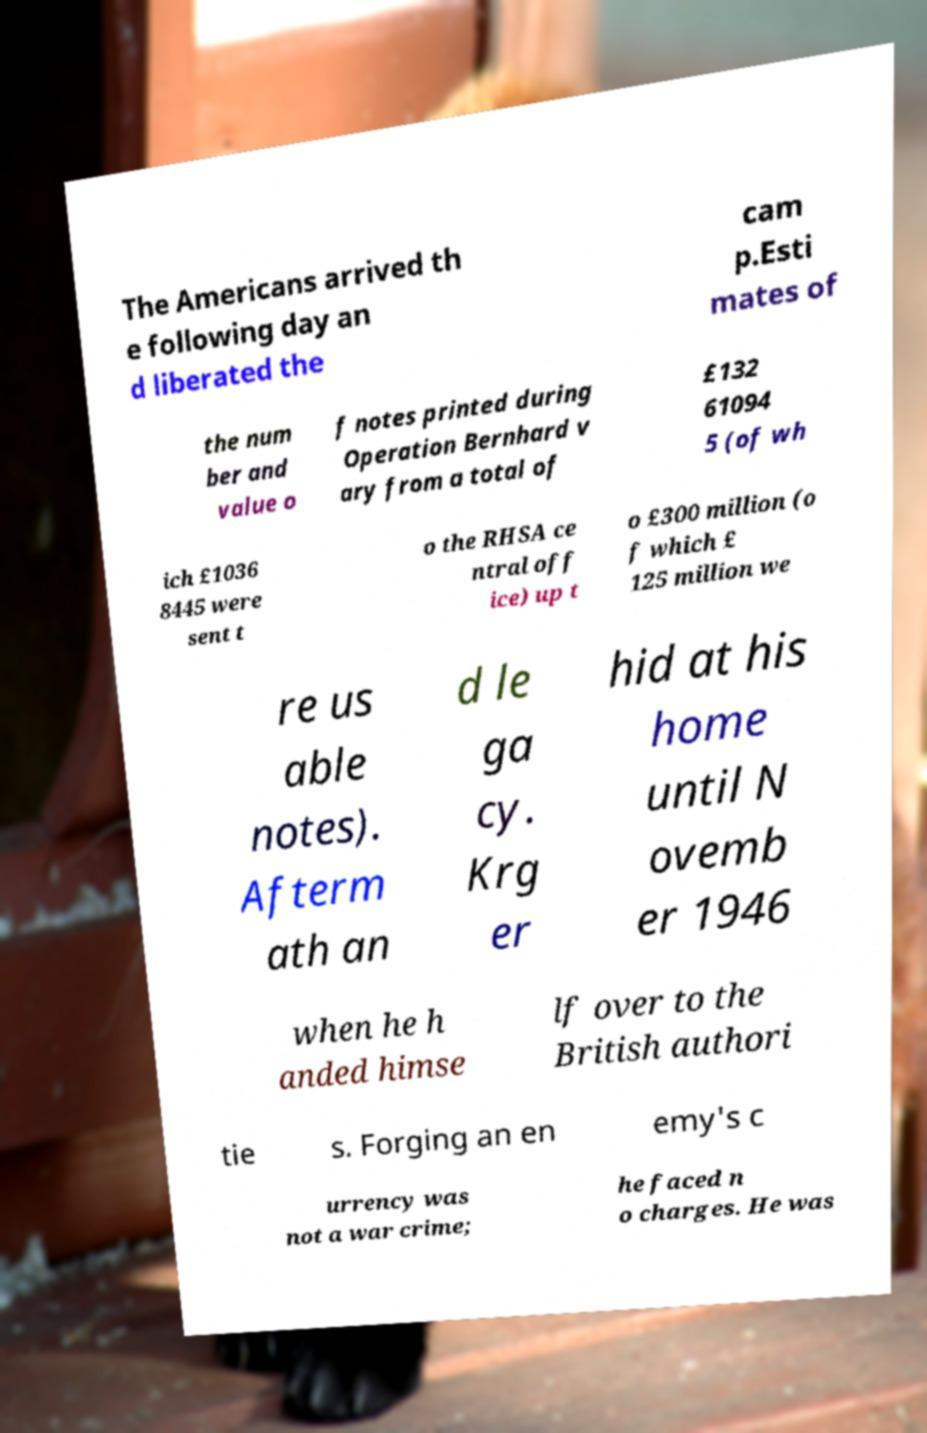Can you read and provide the text displayed in the image?This photo seems to have some interesting text. Can you extract and type it out for me? The Americans arrived th e following day an d liberated the cam p.Esti mates of the num ber and value o f notes printed during Operation Bernhard v ary from a total of £132 61094 5 (of wh ich £1036 8445 were sent t o the RHSA ce ntral off ice) up t o £300 million (o f which £ 125 million we re us able notes). Afterm ath an d le ga cy. Krg er hid at his home until N ovemb er 1946 when he h anded himse lf over to the British authori tie s. Forging an en emy's c urrency was not a war crime; he faced n o charges. He was 